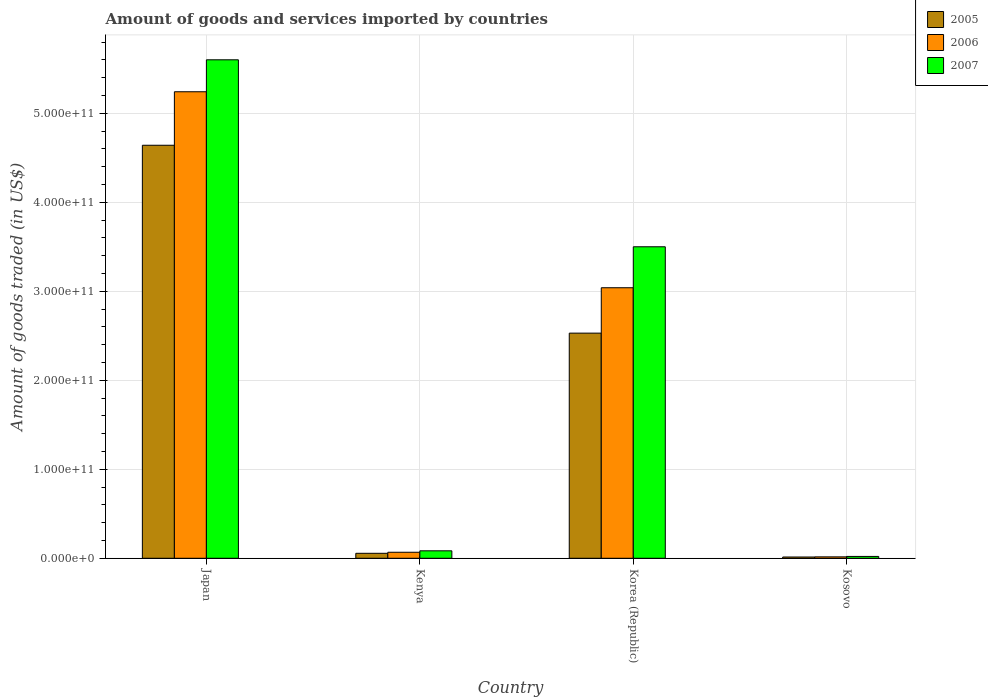Are the number of bars per tick equal to the number of legend labels?
Offer a terse response. Yes. How many bars are there on the 2nd tick from the left?
Make the answer very short. 3. How many bars are there on the 4th tick from the right?
Offer a very short reply. 3. In how many cases, is the number of bars for a given country not equal to the number of legend labels?
Offer a terse response. 0. What is the total amount of goods and services imported in 2007 in Japan?
Your answer should be very brief. 5.60e+11. Across all countries, what is the maximum total amount of goods and services imported in 2005?
Your response must be concise. 4.64e+11. Across all countries, what is the minimum total amount of goods and services imported in 2006?
Ensure brevity in your answer.  1.58e+09. In which country was the total amount of goods and services imported in 2005 minimum?
Keep it short and to the point. Kosovo. What is the total total amount of goods and services imported in 2006 in the graph?
Your response must be concise. 8.36e+11. What is the difference between the total amount of goods and services imported in 2006 in Japan and that in Korea (Republic)?
Your answer should be compact. 2.20e+11. What is the difference between the total amount of goods and services imported in 2007 in Kosovo and the total amount of goods and services imported in 2005 in Japan?
Offer a very short reply. -4.62e+11. What is the average total amount of goods and services imported in 2007 per country?
Ensure brevity in your answer.  2.30e+11. What is the difference between the total amount of goods and services imported of/in 2005 and total amount of goods and services imported of/in 2007 in Kenya?
Ensure brevity in your answer.  -2.78e+09. In how many countries, is the total amount of goods and services imported in 2006 greater than 380000000000 US$?
Give a very brief answer. 1. What is the ratio of the total amount of goods and services imported in 2007 in Kenya to that in Korea (Republic)?
Your answer should be very brief. 0.02. Is the difference between the total amount of goods and services imported in 2005 in Korea (Republic) and Kosovo greater than the difference between the total amount of goods and services imported in 2007 in Korea (Republic) and Kosovo?
Ensure brevity in your answer.  No. What is the difference between the highest and the second highest total amount of goods and services imported in 2006?
Offer a very short reply. 2.20e+11. What is the difference between the highest and the lowest total amount of goods and services imported in 2005?
Your response must be concise. 4.63e+11. Is the sum of the total amount of goods and services imported in 2007 in Japan and Kenya greater than the maximum total amount of goods and services imported in 2005 across all countries?
Give a very brief answer. Yes. What does the 1st bar from the right in Korea (Republic) represents?
Ensure brevity in your answer.  2007. How many bars are there?
Make the answer very short. 12. Are all the bars in the graph horizontal?
Give a very brief answer. No. How many countries are there in the graph?
Provide a succinct answer. 4. What is the difference between two consecutive major ticks on the Y-axis?
Provide a short and direct response. 1.00e+11. Does the graph contain any zero values?
Provide a short and direct response. No. Does the graph contain grids?
Your answer should be compact. Yes. What is the title of the graph?
Your answer should be compact. Amount of goods and services imported by countries. What is the label or title of the X-axis?
Your answer should be compact. Country. What is the label or title of the Y-axis?
Your answer should be very brief. Amount of goods traded (in US$). What is the Amount of goods traded (in US$) in 2005 in Japan?
Your answer should be compact. 4.64e+11. What is the Amount of goods traded (in US$) in 2006 in Japan?
Offer a very short reply. 5.24e+11. What is the Amount of goods traded (in US$) in 2007 in Japan?
Make the answer very short. 5.60e+11. What is the Amount of goods traded (in US$) of 2005 in Kenya?
Keep it short and to the point. 5.59e+09. What is the Amount of goods traded (in US$) of 2006 in Kenya?
Offer a terse response. 6.75e+09. What is the Amount of goods traded (in US$) of 2007 in Kenya?
Your answer should be compact. 8.37e+09. What is the Amount of goods traded (in US$) in 2005 in Korea (Republic)?
Make the answer very short. 2.53e+11. What is the Amount of goods traded (in US$) in 2006 in Korea (Republic)?
Provide a short and direct response. 3.04e+11. What is the Amount of goods traded (in US$) in 2007 in Korea (Republic)?
Your answer should be very brief. 3.50e+11. What is the Amount of goods traded (in US$) of 2005 in Kosovo?
Give a very brief answer. 1.42e+09. What is the Amount of goods traded (in US$) of 2006 in Kosovo?
Offer a very short reply. 1.58e+09. What is the Amount of goods traded (in US$) of 2007 in Kosovo?
Offer a very short reply. 2.08e+09. Across all countries, what is the maximum Amount of goods traded (in US$) of 2005?
Give a very brief answer. 4.64e+11. Across all countries, what is the maximum Amount of goods traded (in US$) in 2006?
Ensure brevity in your answer.  5.24e+11. Across all countries, what is the maximum Amount of goods traded (in US$) in 2007?
Offer a very short reply. 5.60e+11. Across all countries, what is the minimum Amount of goods traded (in US$) in 2005?
Provide a short and direct response. 1.42e+09. Across all countries, what is the minimum Amount of goods traded (in US$) in 2006?
Offer a very short reply. 1.58e+09. Across all countries, what is the minimum Amount of goods traded (in US$) of 2007?
Offer a very short reply. 2.08e+09. What is the total Amount of goods traded (in US$) of 2005 in the graph?
Make the answer very short. 7.24e+11. What is the total Amount of goods traded (in US$) in 2006 in the graph?
Keep it short and to the point. 8.36e+11. What is the total Amount of goods traded (in US$) of 2007 in the graph?
Offer a terse response. 9.20e+11. What is the difference between the Amount of goods traded (in US$) in 2005 in Japan and that in Kenya?
Offer a very short reply. 4.58e+11. What is the difference between the Amount of goods traded (in US$) of 2006 in Japan and that in Kenya?
Give a very brief answer. 5.17e+11. What is the difference between the Amount of goods traded (in US$) in 2007 in Japan and that in Kenya?
Your response must be concise. 5.52e+11. What is the difference between the Amount of goods traded (in US$) of 2005 in Japan and that in Korea (Republic)?
Ensure brevity in your answer.  2.11e+11. What is the difference between the Amount of goods traded (in US$) of 2006 in Japan and that in Korea (Republic)?
Make the answer very short. 2.20e+11. What is the difference between the Amount of goods traded (in US$) in 2007 in Japan and that in Korea (Republic)?
Your answer should be compact. 2.10e+11. What is the difference between the Amount of goods traded (in US$) in 2005 in Japan and that in Kosovo?
Make the answer very short. 4.63e+11. What is the difference between the Amount of goods traded (in US$) in 2006 in Japan and that in Kosovo?
Offer a very short reply. 5.23e+11. What is the difference between the Amount of goods traded (in US$) of 2007 in Japan and that in Kosovo?
Your answer should be compact. 5.58e+11. What is the difference between the Amount of goods traded (in US$) of 2005 in Kenya and that in Korea (Republic)?
Provide a succinct answer. -2.47e+11. What is the difference between the Amount of goods traded (in US$) in 2006 in Kenya and that in Korea (Republic)?
Give a very brief answer. -2.97e+11. What is the difference between the Amount of goods traded (in US$) of 2007 in Kenya and that in Korea (Republic)?
Make the answer very short. -3.42e+11. What is the difference between the Amount of goods traded (in US$) of 2005 in Kenya and that in Kosovo?
Your answer should be compact. 4.16e+09. What is the difference between the Amount of goods traded (in US$) in 2006 in Kenya and that in Kosovo?
Provide a short and direct response. 5.17e+09. What is the difference between the Amount of goods traded (in US$) in 2007 in Kenya and that in Kosovo?
Keep it short and to the point. 6.29e+09. What is the difference between the Amount of goods traded (in US$) of 2005 in Korea (Republic) and that in Kosovo?
Give a very brief answer. 2.52e+11. What is the difference between the Amount of goods traded (in US$) in 2006 in Korea (Republic) and that in Kosovo?
Keep it short and to the point. 3.02e+11. What is the difference between the Amount of goods traded (in US$) of 2007 in Korea (Republic) and that in Kosovo?
Ensure brevity in your answer.  3.48e+11. What is the difference between the Amount of goods traded (in US$) in 2005 in Japan and the Amount of goods traded (in US$) in 2006 in Kenya?
Make the answer very short. 4.57e+11. What is the difference between the Amount of goods traded (in US$) of 2005 in Japan and the Amount of goods traded (in US$) of 2007 in Kenya?
Provide a succinct answer. 4.56e+11. What is the difference between the Amount of goods traded (in US$) of 2006 in Japan and the Amount of goods traded (in US$) of 2007 in Kenya?
Offer a terse response. 5.16e+11. What is the difference between the Amount of goods traded (in US$) in 2005 in Japan and the Amount of goods traded (in US$) in 2006 in Korea (Republic)?
Your answer should be compact. 1.60e+11. What is the difference between the Amount of goods traded (in US$) in 2005 in Japan and the Amount of goods traded (in US$) in 2007 in Korea (Republic)?
Your answer should be compact. 1.14e+11. What is the difference between the Amount of goods traded (in US$) of 2006 in Japan and the Amount of goods traded (in US$) of 2007 in Korea (Republic)?
Provide a succinct answer. 1.74e+11. What is the difference between the Amount of goods traded (in US$) of 2005 in Japan and the Amount of goods traded (in US$) of 2006 in Kosovo?
Offer a terse response. 4.62e+11. What is the difference between the Amount of goods traded (in US$) in 2005 in Japan and the Amount of goods traded (in US$) in 2007 in Kosovo?
Provide a short and direct response. 4.62e+11. What is the difference between the Amount of goods traded (in US$) of 2006 in Japan and the Amount of goods traded (in US$) of 2007 in Kosovo?
Provide a short and direct response. 5.22e+11. What is the difference between the Amount of goods traded (in US$) in 2005 in Kenya and the Amount of goods traded (in US$) in 2006 in Korea (Republic)?
Ensure brevity in your answer.  -2.98e+11. What is the difference between the Amount of goods traded (in US$) of 2005 in Kenya and the Amount of goods traded (in US$) of 2007 in Korea (Republic)?
Offer a terse response. -3.44e+11. What is the difference between the Amount of goods traded (in US$) of 2006 in Kenya and the Amount of goods traded (in US$) of 2007 in Korea (Republic)?
Offer a terse response. -3.43e+11. What is the difference between the Amount of goods traded (in US$) of 2005 in Kenya and the Amount of goods traded (in US$) of 2006 in Kosovo?
Provide a succinct answer. 4.00e+09. What is the difference between the Amount of goods traded (in US$) of 2005 in Kenya and the Amount of goods traded (in US$) of 2007 in Kosovo?
Provide a short and direct response. 3.51e+09. What is the difference between the Amount of goods traded (in US$) in 2006 in Kenya and the Amount of goods traded (in US$) in 2007 in Kosovo?
Give a very brief answer. 4.68e+09. What is the difference between the Amount of goods traded (in US$) of 2005 in Korea (Republic) and the Amount of goods traded (in US$) of 2006 in Kosovo?
Provide a succinct answer. 2.51e+11. What is the difference between the Amount of goods traded (in US$) of 2005 in Korea (Republic) and the Amount of goods traded (in US$) of 2007 in Kosovo?
Your answer should be compact. 2.51e+11. What is the difference between the Amount of goods traded (in US$) of 2006 in Korea (Republic) and the Amount of goods traded (in US$) of 2007 in Kosovo?
Provide a succinct answer. 3.02e+11. What is the average Amount of goods traded (in US$) in 2005 per country?
Provide a short and direct response. 1.81e+11. What is the average Amount of goods traded (in US$) in 2006 per country?
Keep it short and to the point. 2.09e+11. What is the average Amount of goods traded (in US$) in 2007 per country?
Your answer should be very brief. 2.30e+11. What is the difference between the Amount of goods traded (in US$) in 2005 and Amount of goods traded (in US$) in 2006 in Japan?
Your answer should be compact. -6.01e+1. What is the difference between the Amount of goods traded (in US$) of 2005 and Amount of goods traded (in US$) of 2007 in Japan?
Your response must be concise. -9.60e+1. What is the difference between the Amount of goods traded (in US$) in 2006 and Amount of goods traded (in US$) in 2007 in Japan?
Your response must be concise. -3.59e+1. What is the difference between the Amount of goods traded (in US$) in 2005 and Amount of goods traded (in US$) in 2006 in Kenya?
Provide a short and direct response. -1.17e+09. What is the difference between the Amount of goods traded (in US$) of 2005 and Amount of goods traded (in US$) of 2007 in Kenya?
Provide a succinct answer. -2.78e+09. What is the difference between the Amount of goods traded (in US$) in 2006 and Amount of goods traded (in US$) in 2007 in Kenya?
Your answer should be compact. -1.62e+09. What is the difference between the Amount of goods traded (in US$) of 2005 and Amount of goods traded (in US$) of 2006 in Korea (Republic)?
Your answer should be compact. -5.10e+1. What is the difference between the Amount of goods traded (in US$) of 2005 and Amount of goods traded (in US$) of 2007 in Korea (Republic)?
Your answer should be compact. -9.70e+1. What is the difference between the Amount of goods traded (in US$) in 2006 and Amount of goods traded (in US$) in 2007 in Korea (Republic)?
Offer a terse response. -4.60e+1. What is the difference between the Amount of goods traded (in US$) of 2005 and Amount of goods traded (in US$) of 2006 in Kosovo?
Offer a very short reply. -1.61e+08. What is the difference between the Amount of goods traded (in US$) of 2005 and Amount of goods traded (in US$) of 2007 in Kosovo?
Provide a short and direct response. -6.53e+08. What is the difference between the Amount of goods traded (in US$) in 2006 and Amount of goods traded (in US$) in 2007 in Kosovo?
Your answer should be very brief. -4.92e+08. What is the ratio of the Amount of goods traded (in US$) of 2005 in Japan to that in Kenya?
Keep it short and to the point. 83.06. What is the ratio of the Amount of goods traded (in US$) in 2006 in Japan to that in Kenya?
Your response must be concise. 77.62. What is the ratio of the Amount of goods traded (in US$) in 2007 in Japan to that in Kenya?
Your answer should be compact. 66.92. What is the ratio of the Amount of goods traded (in US$) of 2005 in Japan to that in Korea (Republic)?
Provide a succinct answer. 1.83. What is the ratio of the Amount of goods traded (in US$) of 2006 in Japan to that in Korea (Republic)?
Offer a very short reply. 1.72. What is the ratio of the Amount of goods traded (in US$) of 2007 in Japan to that in Korea (Republic)?
Make the answer very short. 1.6. What is the ratio of the Amount of goods traded (in US$) of 2005 in Japan to that in Kosovo?
Make the answer very short. 326.15. What is the ratio of the Amount of goods traded (in US$) of 2006 in Japan to that in Kosovo?
Offer a terse response. 330.99. What is the ratio of the Amount of goods traded (in US$) in 2007 in Japan to that in Kosovo?
Ensure brevity in your answer.  269.84. What is the ratio of the Amount of goods traded (in US$) in 2005 in Kenya to that in Korea (Republic)?
Your response must be concise. 0.02. What is the ratio of the Amount of goods traded (in US$) of 2006 in Kenya to that in Korea (Republic)?
Ensure brevity in your answer.  0.02. What is the ratio of the Amount of goods traded (in US$) in 2007 in Kenya to that in Korea (Republic)?
Your answer should be very brief. 0.02. What is the ratio of the Amount of goods traded (in US$) of 2005 in Kenya to that in Kosovo?
Keep it short and to the point. 3.93. What is the ratio of the Amount of goods traded (in US$) in 2006 in Kenya to that in Kosovo?
Keep it short and to the point. 4.26. What is the ratio of the Amount of goods traded (in US$) in 2007 in Kenya to that in Kosovo?
Offer a terse response. 4.03. What is the ratio of the Amount of goods traded (in US$) in 2005 in Korea (Republic) to that in Kosovo?
Offer a very short reply. 177.79. What is the ratio of the Amount of goods traded (in US$) in 2006 in Korea (Republic) to that in Kosovo?
Give a very brief answer. 191.94. What is the ratio of the Amount of goods traded (in US$) in 2007 in Korea (Republic) to that in Kosovo?
Make the answer very short. 168.62. What is the difference between the highest and the second highest Amount of goods traded (in US$) in 2005?
Offer a very short reply. 2.11e+11. What is the difference between the highest and the second highest Amount of goods traded (in US$) in 2006?
Your answer should be compact. 2.20e+11. What is the difference between the highest and the second highest Amount of goods traded (in US$) of 2007?
Provide a short and direct response. 2.10e+11. What is the difference between the highest and the lowest Amount of goods traded (in US$) of 2005?
Provide a short and direct response. 4.63e+11. What is the difference between the highest and the lowest Amount of goods traded (in US$) in 2006?
Provide a short and direct response. 5.23e+11. What is the difference between the highest and the lowest Amount of goods traded (in US$) of 2007?
Your response must be concise. 5.58e+11. 